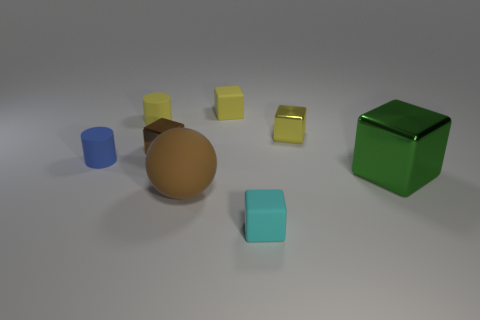What size is the yellow block that is the same material as the big green block?
Provide a short and direct response. Small. Do the metallic cube that is in front of the blue rubber object and the brown object in front of the green block have the same size?
Provide a short and direct response. Yes. What number of things are yellow cubes that are right of the cyan rubber thing or big balls?
Keep it short and to the point. 2. Are there fewer big purple shiny things than tiny rubber cylinders?
Your answer should be very brief. Yes. There is a large thing that is on the right side of the matte block that is behind the metal thing that is in front of the small brown shiny block; what is its shape?
Your answer should be very brief. Cube. What shape is the object that is the same color as the large rubber ball?
Ensure brevity in your answer.  Cube. Is there a small cyan matte cylinder?
Give a very brief answer. No. Does the blue thing have the same size as the cylinder that is behind the small brown thing?
Your answer should be very brief. Yes. There is a small matte object in front of the large cube; are there any large matte spheres in front of it?
Keep it short and to the point. No. There is a yellow object that is on the right side of the yellow cylinder and to the left of the cyan object; what is it made of?
Provide a succinct answer. Rubber. 